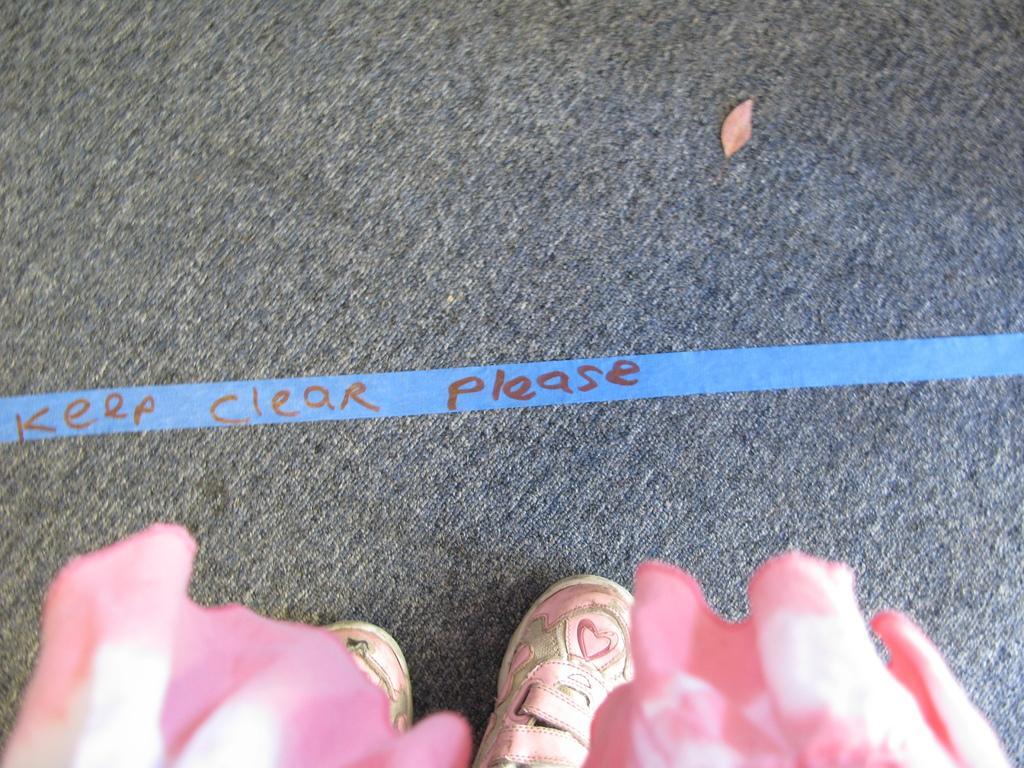How would you summarize this image in a sentence or two? At the bottom of the image there are two shoes and there is a cloth which is pink in color. In the middle of the image there is a mat and there is a text on the ribbon. 